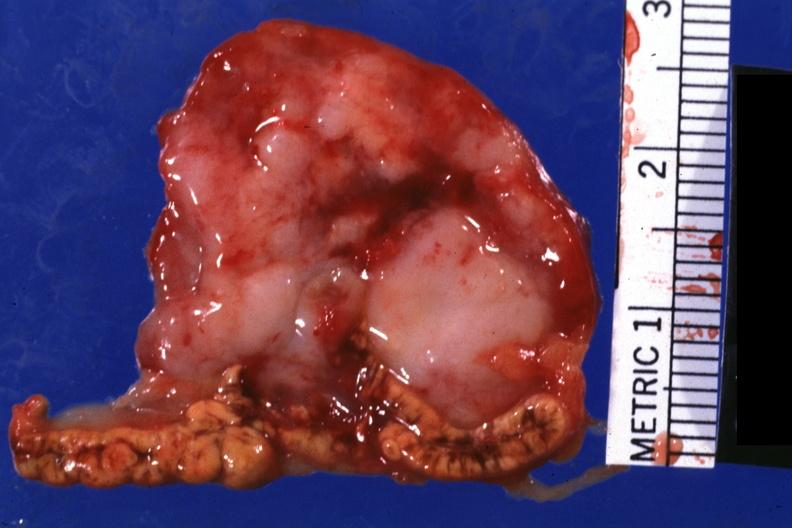what is present?
Answer the question using a single word or phrase. Adrenal 